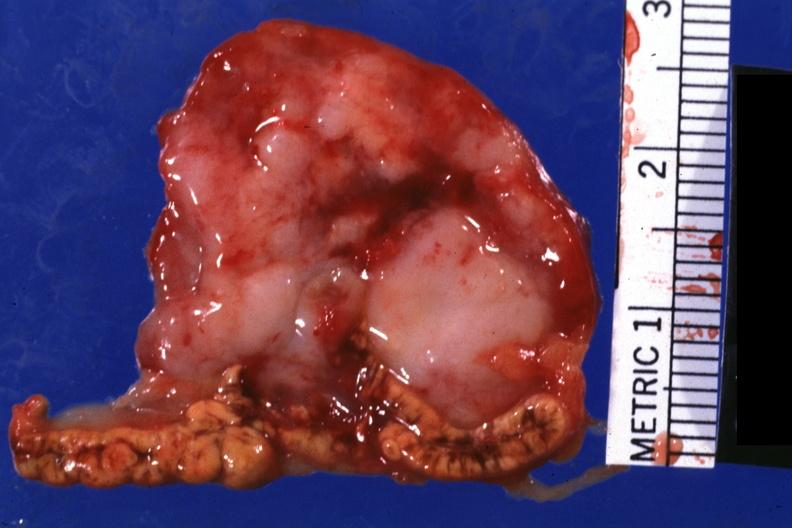what is present?
Answer the question using a single word or phrase. Adrenal 